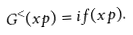<formula> <loc_0><loc_0><loc_500><loc_500>G ^ { < } ( x p ) = i f ( x p ) .</formula> 